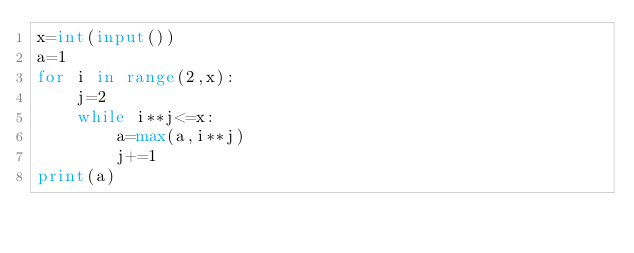<code> <loc_0><loc_0><loc_500><loc_500><_Python_>x=int(input())
a=1
for i in range(2,x):
    j=2
    while i**j<=x:
        a=max(a,i**j)
        j+=1
print(a)</code> 